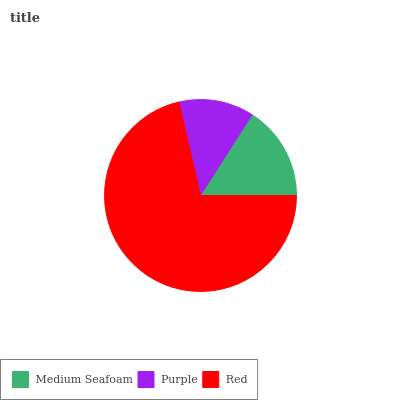Is Purple the minimum?
Answer yes or no. Yes. Is Red the maximum?
Answer yes or no. Yes. Is Red the minimum?
Answer yes or no. No. Is Purple the maximum?
Answer yes or no. No. Is Red greater than Purple?
Answer yes or no. Yes. Is Purple less than Red?
Answer yes or no. Yes. Is Purple greater than Red?
Answer yes or no. No. Is Red less than Purple?
Answer yes or no. No. Is Medium Seafoam the high median?
Answer yes or no. Yes. Is Medium Seafoam the low median?
Answer yes or no. Yes. Is Red the high median?
Answer yes or no. No. Is Purple the low median?
Answer yes or no. No. 